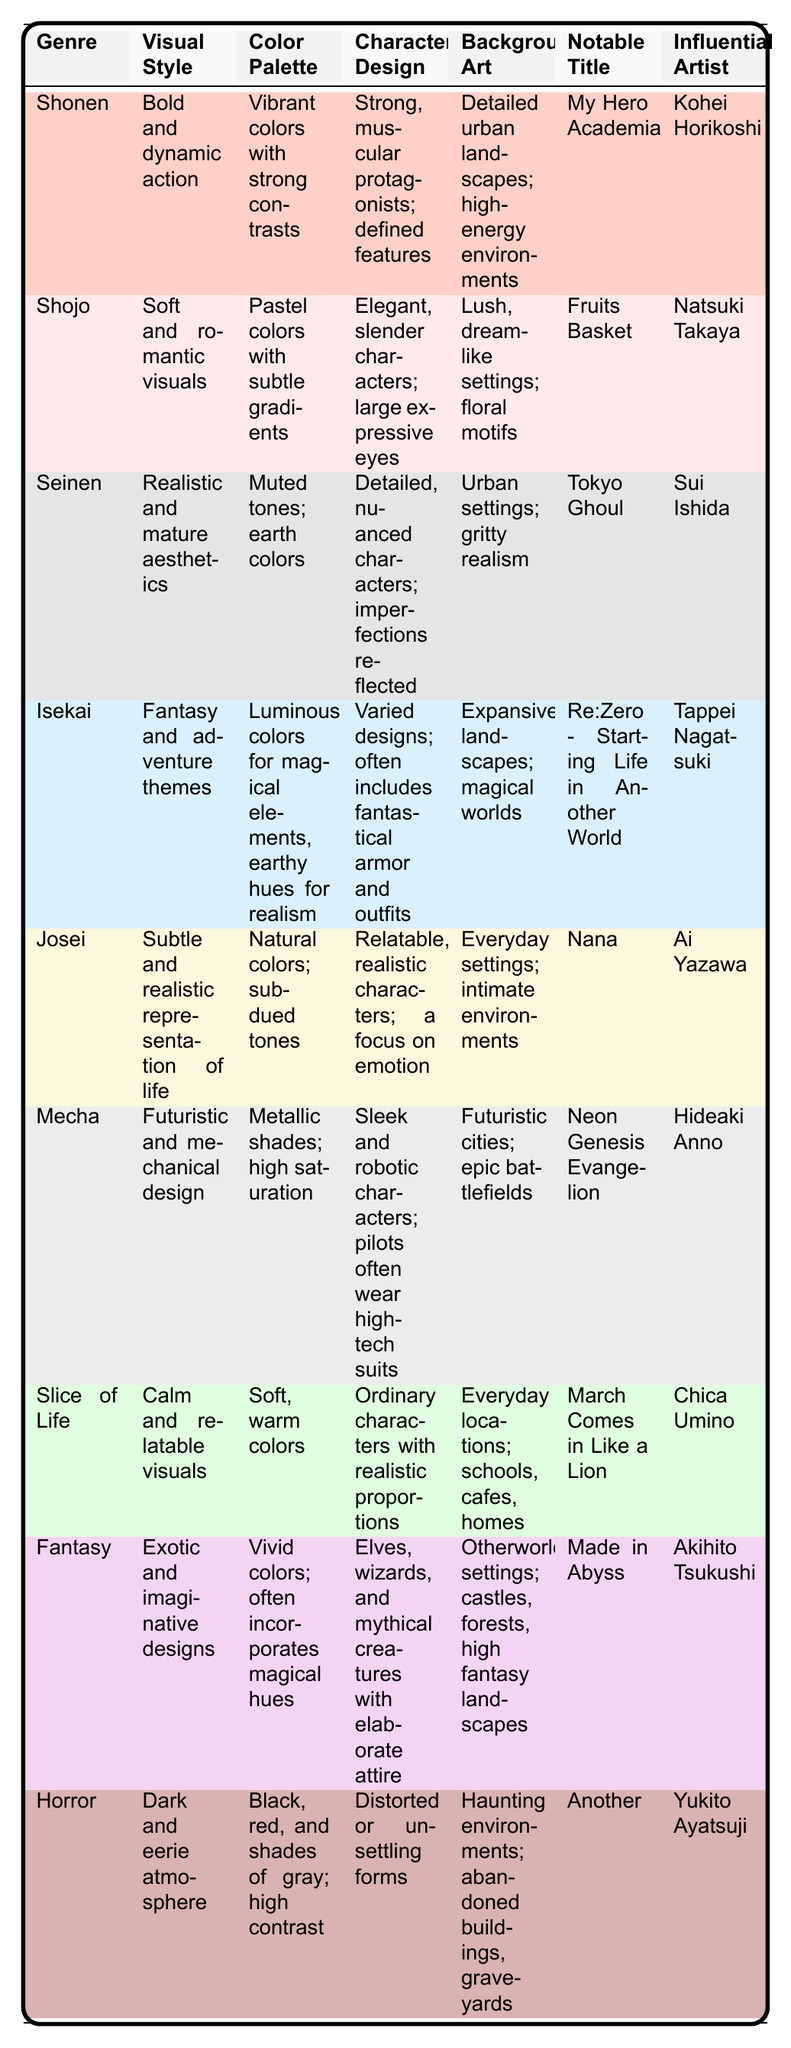What is the color palette used in the Shonen genre? The table specifies the color palette for the Shonen genre as "Vibrant colors with strong contrasts."
Answer: Vibrant colors with strong contrasts Which genre features a visual style described as "Soft and romantic visuals"? The Shojo genre is described as having a visual style of "Soft and romantic visuals" in the table.
Answer: Shojo List the notable title for the Fantasy genre. According to the table, the notable title for the Fantasy genre is "Made in Abyss."
Answer: Made in Abyss What visual styles are associated with the Seinen and Josei genres? The visual style for Seinen is "Realistic and mature aesthetics," while for Josei it is "Subtle and realistic representation of life."
Answer: Seinen: Realistic and mature aesthetics; Josei: Subtle and realistic representation of life Which genre's character design includes "Ordinary characters with realistic proportions"? This character design description aligns with the Slice of Life genre.
Answer: Slice of Life Is the background art for the Horror genre characterized by "Everyday settings; schools, cafes, homes"? No, that's not true. The Horror genre features background art described as "Haunting environments; abandoned buildings, graveyards."
Answer: No How many genres have a color palette that includes pastel colors? Only the Shojo genre has a color palette described as "Pastel colors with subtle gradients." Therefore, the count is 1.
Answer: 1 Which genre has the most vibrant color palette? The Shonen genre has the most vibrant color palette, which is described as "Vibrant colors with strong contrasts" compared to others that are more subdued or muted.
Answer: Shonen Are there any genres that focus on fantasy themes in both visual style and character design? Yes, both the Isekai and Fantasy genres focus on fantasy themes, with descriptions that highlight adventure and exotic designs.
Answer: Yes What can be inferred about the emotional tone of the Josei and Slice of Life genres based on visual design? Both genres emphasize relatable characters and settings, with Josei focusing on emotional depth and Slice of Life on calmness, suggesting a connectivity to life experiences and emotions.
Answer: They both emphasize relatable emotional tones 